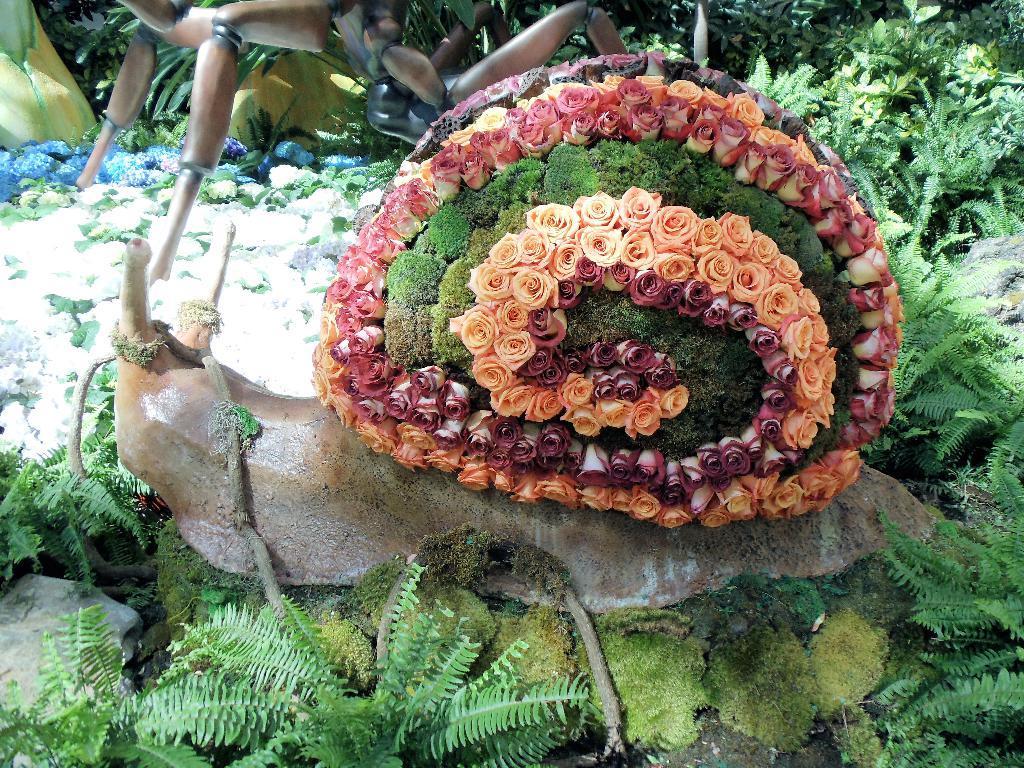Describe this image in one or two sentences. In this picture, we can see the ground with plants, flowers, rocks, and some decorative objects. 